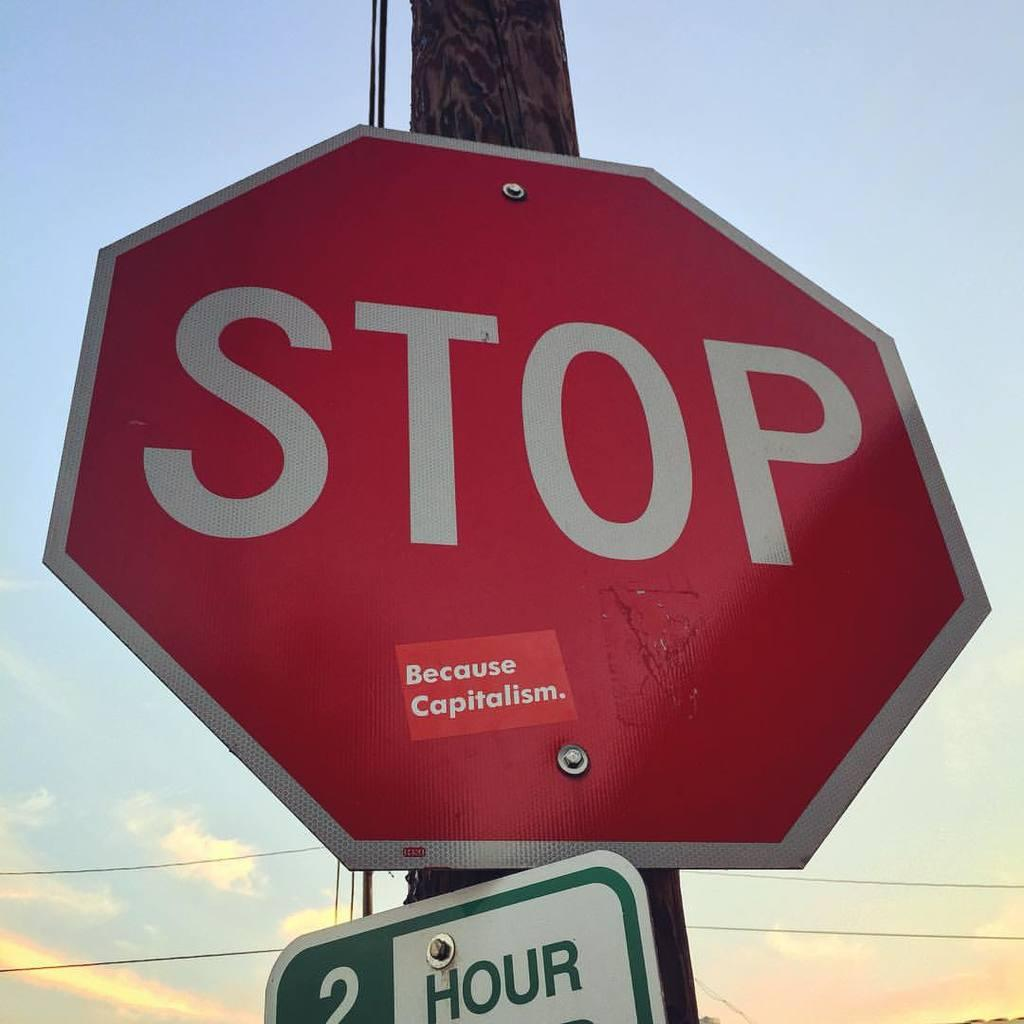<image>
Render a clear and concise summary of the photo. a close up of a Stop sign with a 2 hour sign under it 